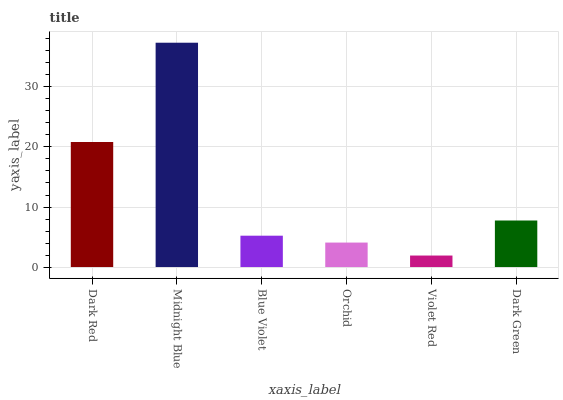Is Violet Red the minimum?
Answer yes or no. Yes. Is Midnight Blue the maximum?
Answer yes or no. Yes. Is Blue Violet the minimum?
Answer yes or no. No. Is Blue Violet the maximum?
Answer yes or no. No. Is Midnight Blue greater than Blue Violet?
Answer yes or no. Yes. Is Blue Violet less than Midnight Blue?
Answer yes or no. Yes. Is Blue Violet greater than Midnight Blue?
Answer yes or no. No. Is Midnight Blue less than Blue Violet?
Answer yes or no. No. Is Dark Green the high median?
Answer yes or no. Yes. Is Blue Violet the low median?
Answer yes or no. Yes. Is Dark Red the high median?
Answer yes or no. No. Is Dark Green the low median?
Answer yes or no. No. 